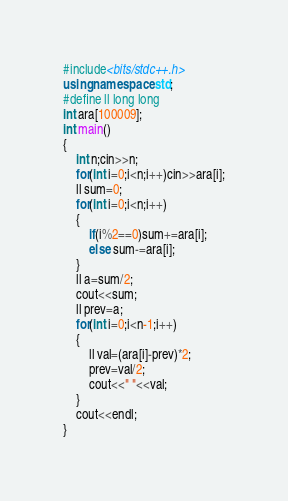Convert code to text. <code><loc_0><loc_0><loc_500><loc_500><_C++_>#include<bits/stdc++.h>
using namespace std;
#define ll long long
int ara[100009];
int main()
{
    int n;cin>>n;
    for(int i=0;i<n;i++)cin>>ara[i];
    ll sum=0;
    for(int i=0;i<n;i++)
    {
        if(i%2==0)sum+=ara[i];
        else sum-=ara[i];
    }
    ll a=sum/2;
    cout<<sum;
    ll prev=a;
    for(int i=0;i<n-1;i++)
    {
        ll val=(ara[i]-prev)*2;
        prev=val/2;
        cout<<" "<<val;
    }
    cout<<endl;
}
</code> 